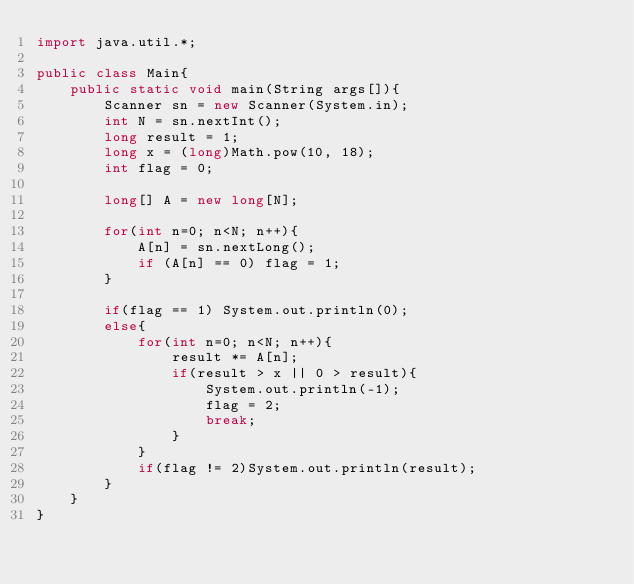<code> <loc_0><loc_0><loc_500><loc_500><_Java_>import java.util.*;

public class Main{
    public static void main(String args[]){
        Scanner sn = new Scanner(System.in);
        int N = sn.nextInt();
        long result = 1;
        long x = (long)Math.pow(10, 18);
        int flag = 0;

        long[] A = new long[N];

        for(int n=0; n<N; n++){
            A[n] = sn.nextLong();
            if (A[n] == 0) flag = 1;
        }

        if(flag == 1) System.out.println(0);
        else{
            for(int n=0; n<N; n++){
                result *= A[n];
                if(result > x || 0 > result){
                    System.out.println(-1);
                    flag = 2;
                    break;
                }
            }
            if(flag != 2)System.out.println(result);
        }
    }
}</code> 